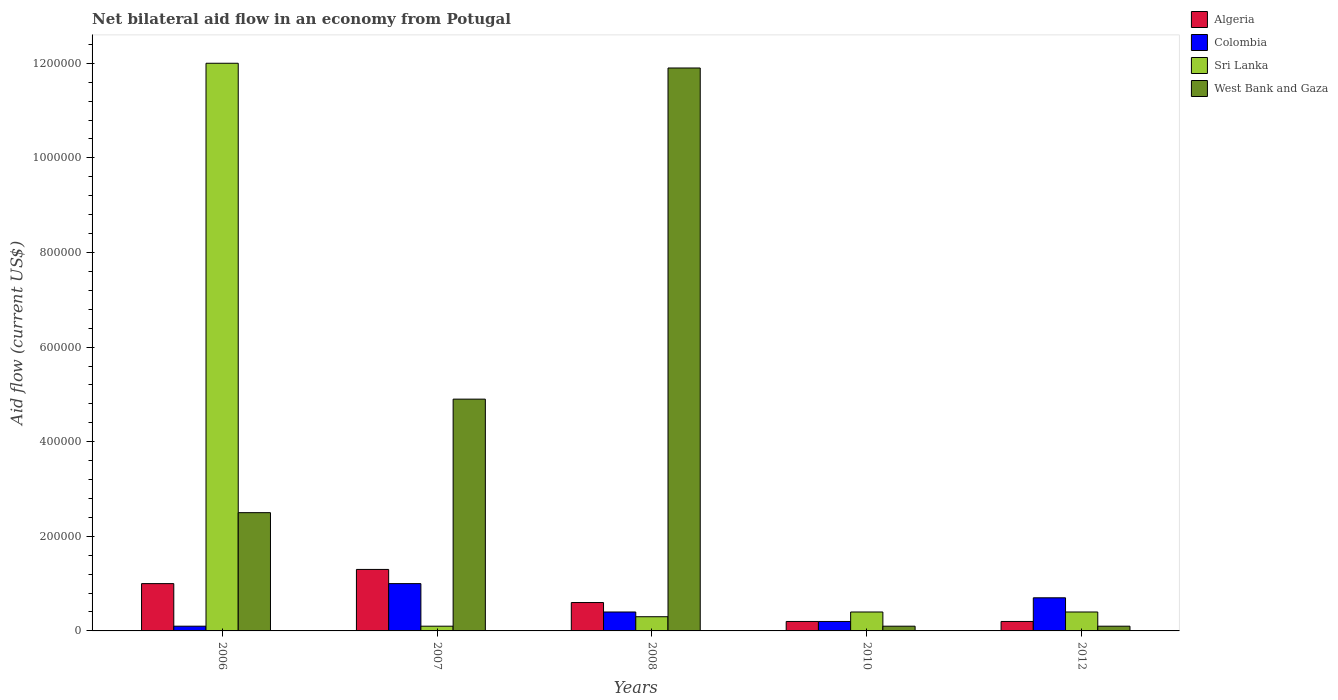How many groups of bars are there?
Provide a short and direct response. 5. Are the number of bars per tick equal to the number of legend labels?
Make the answer very short. Yes. Are the number of bars on each tick of the X-axis equal?
Ensure brevity in your answer.  Yes. How many bars are there on the 5th tick from the right?
Give a very brief answer. 4. In how many cases, is the number of bars for a given year not equal to the number of legend labels?
Your response must be concise. 0. What is the net bilateral aid flow in Sri Lanka in 2010?
Ensure brevity in your answer.  4.00e+04. In which year was the net bilateral aid flow in West Bank and Gaza maximum?
Give a very brief answer. 2008. What is the total net bilateral aid flow in Sri Lanka in the graph?
Offer a very short reply. 1.32e+06. What is the average net bilateral aid flow in Sri Lanka per year?
Provide a succinct answer. 2.64e+05. What is the ratio of the net bilateral aid flow in West Bank and Gaza in 2010 to that in 2012?
Your answer should be compact. 1. Is the difference between the net bilateral aid flow in Colombia in 2007 and 2008 greater than the difference between the net bilateral aid flow in Sri Lanka in 2007 and 2008?
Offer a terse response. Yes. What is the difference between the highest and the second highest net bilateral aid flow in Colombia?
Your answer should be compact. 3.00e+04. What is the difference between the highest and the lowest net bilateral aid flow in Algeria?
Your answer should be compact. 1.10e+05. In how many years, is the net bilateral aid flow in Algeria greater than the average net bilateral aid flow in Algeria taken over all years?
Offer a terse response. 2. Is the sum of the net bilateral aid flow in West Bank and Gaza in 2007 and 2012 greater than the maximum net bilateral aid flow in Colombia across all years?
Offer a very short reply. Yes. Is it the case that in every year, the sum of the net bilateral aid flow in Sri Lanka and net bilateral aid flow in West Bank and Gaza is greater than the sum of net bilateral aid flow in Colombia and net bilateral aid flow in Algeria?
Keep it short and to the point. Yes. What does the 4th bar from the left in 2010 represents?
Offer a terse response. West Bank and Gaza. What does the 2nd bar from the right in 2010 represents?
Make the answer very short. Sri Lanka. Is it the case that in every year, the sum of the net bilateral aid flow in Colombia and net bilateral aid flow in Algeria is greater than the net bilateral aid flow in West Bank and Gaza?
Your answer should be compact. No. How many bars are there?
Make the answer very short. 20. Are the values on the major ticks of Y-axis written in scientific E-notation?
Your response must be concise. No. Does the graph contain any zero values?
Offer a terse response. No. Where does the legend appear in the graph?
Your response must be concise. Top right. How many legend labels are there?
Keep it short and to the point. 4. What is the title of the graph?
Your response must be concise. Net bilateral aid flow in an economy from Potugal. What is the Aid flow (current US$) of Sri Lanka in 2006?
Ensure brevity in your answer.  1.20e+06. What is the Aid flow (current US$) in Algeria in 2007?
Keep it short and to the point. 1.30e+05. What is the Aid flow (current US$) in Sri Lanka in 2007?
Offer a terse response. 10000. What is the Aid flow (current US$) in West Bank and Gaza in 2007?
Make the answer very short. 4.90e+05. What is the Aid flow (current US$) of Algeria in 2008?
Your response must be concise. 6.00e+04. What is the Aid flow (current US$) in Colombia in 2008?
Keep it short and to the point. 4.00e+04. What is the Aid flow (current US$) of Sri Lanka in 2008?
Your response must be concise. 3.00e+04. What is the Aid flow (current US$) in West Bank and Gaza in 2008?
Offer a terse response. 1.19e+06. What is the Aid flow (current US$) in Colombia in 2010?
Offer a terse response. 2.00e+04. What is the Aid flow (current US$) of Algeria in 2012?
Offer a terse response. 2.00e+04. What is the Aid flow (current US$) of Sri Lanka in 2012?
Ensure brevity in your answer.  4.00e+04. Across all years, what is the maximum Aid flow (current US$) in Sri Lanka?
Your answer should be very brief. 1.20e+06. Across all years, what is the maximum Aid flow (current US$) of West Bank and Gaza?
Provide a short and direct response. 1.19e+06. Across all years, what is the minimum Aid flow (current US$) in Algeria?
Provide a succinct answer. 2.00e+04. Across all years, what is the minimum Aid flow (current US$) in West Bank and Gaza?
Make the answer very short. 10000. What is the total Aid flow (current US$) in Algeria in the graph?
Ensure brevity in your answer.  3.30e+05. What is the total Aid flow (current US$) of Colombia in the graph?
Ensure brevity in your answer.  2.40e+05. What is the total Aid flow (current US$) in Sri Lanka in the graph?
Your answer should be very brief. 1.32e+06. What is the total Aid flow (current US$) in West Bank and Gaza in the graph?
Give a very brief answer. 1.95e+06. What is the difference between the Aid flow (current US$) of Sri Lanka in 2006 and that in 2007?
Your answer should be very brief. 1.19e+06. What is the difference between the Aid flow (current US$) in West Bank and Gaza in 2006 and that in 2007?
Your answer should be compact. -2.40e+05. What is the difference between the Aid flow (current US$) in Algeria in 2006 and that in 2008?
Offer a very short reply. 4.00e+04. What is the difference between the Aid flow (current US$) in Sri Lanka in 2006 and that in 2008?
Make the answer very short. 1.17e+06. What is the difference between the Aid flow (current US$) of West Bank and Gaza in 2006 and that in 2008?
Give a very brief answer. -9.40e+05. What is the difference between the Aid flow (current US$) of Sri Lanka in 2006 and that in 2010?
Your answer should be very brief. 1.16e+06. What is the difference between the Aid flow (current US$) of West Bank and Gaza in 2006 and that in 2010?
Make the answer very short. 2.40e+05. What is the difference between the Aid flow (current US$) of Algeria in 2006 and that in 2012?
Offer a terse response. 8.00e+04. What is the difference between the Aid flow (current US$) of Sri Lanka in 2006 and that in 2012?
Provide a succinct answer. 1.16e+06. What is the difference between the Aid flow (current US$) of Algeria in 2007 and that in 2008?
Provide a succinct answer. 7.00e+04. What is the difference between the Aid flow (current US$) of Colombia in 2007 and that in 2008?
Ensure brevity in your answer.  6.00e+04. What is the difference between the Aid flow (current US$) of Sri Lanka in 2007 and that in 2008?
Offer a terse response. -2.00e+04. What is the difference between the Aid flow (current US$) in West Bank and Gaza in 2007 and that in 2008?
Your response must be concise. -7.00e+05. What is the difference between the Aid flow (current US$) of Colombia in 2007 and that in 2010?
Your response must be concise. 8.00e+04. What is the difference between the Aid flow (current US$) of West Bank and Gaza in 2007 and that in 2010?
Ensure brevity in your answer.  4.80e+05. What is the difference between the Aid flow (current US$) in Algeria in 2007 and that in 2012?
Offer a terse response. 1.10e+05. What is the difference between the Aid flow (current US$) in Colombia in 2007 and that in 2012?
Your answer should be compact. 3.00e+04. What is the difference between the Aid flow (current US$) of West Bank and Gaza in 2007 and that in 2012?
Give a very brief answer. 4.80e+05. What is the difference between the Aid flow (current US$) in West Bank and Gaza in 2008 and that in 2010?
Your answer should be very brief. 1.18e+06. What is the difference between the Aid flow (current US$) of Colombia in 2008 and that in 2012?
Your answer should be compact. -3.00e+04. What is the difference between the Aid flow (current US$) in West Bank and Gaza in 2008 and that in 2012?
Keep it short and to the point. 1.18e+06. What is the difference between the Aid flow (current US$) in Algeria in 2010 and that in 2012?
Provide a succinct answer. 0. What is the difference between the Aid flow (current US$) of Sri Lanka in 2010 and that in 2012?
Your answer should be very brief. 0. What is the difference between the Aid flow (current US$) of West Bank and Gaza in 2010 and that in 2012?
Keep it short and to the point. 0. What is the difference between the Aid flow (current US$) in Algeria in 2006 and the Aid flow (current US$) in West Bank and Gaza in 2007?
Give a very brief answer. -3.90e+05. What is the difference between the Aid flow (current US$) of Colombia in 2006 and the Aid flow (current US$) of Sri Lanka in 2007?
Provide a succinct answer. 0. What is the difference between the Aid flow (current US$) in Colombia in 2006 and the Aid flow (current US$) in West Bank and Gaza in 2007?
Make the answer very short. -4.80e+05. What is the difference between the Aid flow (current US$) of Sri Lanka in 2006 and the Aid flow (current US$) of West Bank and Gaza in 2007?
Offer a very short reply. 7.10e+05. What is the difference between the Aid flow (current US$) in Algeria in 2006 and the Aid flow (current US$) in Colombia in 2008?
Make the answer very short. 6.00e+04. What is the difference between the Aid flow (current US$) in Algeria in 2006 and the Aid flow (current US$) in Sri Lanka in 2008?
Keep it short and to the point. 7.00e+04. What is the difference between the Aid flow (current US$) in Algeria in 2006 and the Aid flow (current US$) in West Bank and Gaza in 2008?
Provide a short and direct response. -1.09e+06. What is the difference between the Aid flow (current US$) of Colombia in 2006 and the Aid flow (current US$) of West Bank and Gaza in 2008?
Offer a very short reply. -1.18e+06. What is the difference between the Aid flow (current US$) of Algeria in 2006 and the Aid flow (current US$) of Colombia in 2010?
Make the answer very short. 8.00e+04. What is the difference between the Aid flow (current US$) of Algeria in 2006 and the Aid flow (current US$) of Sri Lanka in 2010?
Provide a short and direct response. 6.00e+04. What is the difference between the Aid flow (current US$) in Algeria in 2006 and the Aid flow (current US$) in West Bank and Gaza in 2010?
Ensure brevity in your answer.  9.00e+04. What is the difference between the Aid flow (current US$) in Sri Lanka in 2006 and the Aid flow (current US$) in West Bank and Gaza in 2010?
Provide a succinct answer. 1.19e+06. What is the difference between the Aid flow (current US$) of Colombia in 2006 and the Aid flow (current US$) of Sri Lanka in 2012?
Offer a terse response. -3.00e+04. What is the difference between the Aid flow (current US$) in Sri Lanka in 2006 and the Aid flow (current US$) in West Bank and Gaza in 2012?
Offer a terse response. 1.19e+06. What is the difference between the Aid flow (current US$) in Algeria in 2007 and the Aid flow (current US$) in West Bank and Gaza in 2008?
Keep it short and to the point. -1.06e+06. What is the difference between the Aid flow (current US$) in Colombia in 2007 and the Aid flow (current US$) in Sri Lanka in 2008?
Offer a very short reply. 7.00e+04. What is the difference between the Aid flow (current US$) of Colombia in 2007 and the Aid flow (current US$) of West Bank and Gaza in 2008?
Your response must be concise. -1.09e+06. What is the difference between the Aid flow (current US$) in Sri Lanka in 2007 and the Aid flow (current US$) in West Bank and Gaza in 2008?
Ensure brevity in your answer.  -1.18e+06. What is the difference between the Aid flow (current US$) in Algeria in 2007 and the Aid flow (current US$) in Sri Lanka in 2010?
Your answer should be compact. 9.00e+04. What is the difference between the Aid flow (current US$) of Colombia in 2007 and the Aid flow (current US$) of Sri Lanka in 2010?
Ensure brevity in your answer.  6.00e+04. What is the difference between the Aid flow (current US$) in Colombia in 2007 and the Aid flow (current US$) in West Bank and Gaza in 2010?
Your answer should be very brief. 9.00e+04. What is the difference between the Aid flow (current US$) of Algeria in 2007 and the Aid flow (current US$) of Colombia in 2012?
Ensure brevity in your answer.  6.00e+04. What is the difference between the Aid flow (current US$) in Colombia in 2007 and the Aid flow (current US$) in Sri Lanka in 2012?
Your answer should be very brief. 6.00e+04. What is the difference between the Aid flow (current US$) in Colombia in 2007 and the Aid flow (current US$) in West Bank and Gaza in 2012?
Provide a short and direct response. 9.00e+04. What is the difference between the Aid flow (current US$) in Colombia in 2008 and the Aid flow (current US$) in West Bank and Gaza in 2010?
Provide a succinct answer. 3.00e+04. What is the difference between the Aid flow (current US$) of Sri Lanka in 2008 and the Aid flow (current US$) of West Bank and Gaza in 2010?
Give a very brief answer. 2.00e+04. What is the difference between the Aid flow (current US$) of Algeria in 2008 and the Aid flow (current US$) of Sri Lanka in 2012?
Give a very brief answer. 2.00e+04. What is the difference between the Aid flow (current US$) in Algeria in 2008 and the Aid flow (current US$) in West Bank and Gaza in 2012?
Ensure brevity in your answer.  5.00e+04. What is the difference between the Aid flow (current US$) in Colombia in 2008 and the Aid flow (current US$) in Sri Lanka in 2012?
Make the answer very short. 0. What is the difference between the Aid flow (current US$) in Colombia in 2008 and the Aid flow (current US$) in West Bank and Gaza in 2012?
Your response must be concise. 3.00e+04. What is the difference between the Aid flow (current US$) in Sri Lanka in 2008 and the Aid flow (current US$) in West Bank and Gaza in 2012?
Keep it short and to the point. 2.00e+04. What is the difference between the Aid flow (current US$) of Algeria in 2010 and the Aid flow (current US$) of Sri Lanka in 2012?
Give a very brief answer. -2.00e+04. What is the difference between the Aid flow (current US$) in Colombia in 2010 and the Aid flow (current US$) in Sri Lanka in 2012?
Provide a succinct answer. -2.00e+04. What is the average Aid flow (current US$) of Algeria per year?
Offer a terse response. 6.60e+04. What is the average Aid flow (current US$) in Colombia per year?
Give a very brief answer. 4.80e+04. What is the average Aid flow (current US$) of Sri Lanka per year?
Provide a succinct answer. 2.64e+05. In the year 2006, what is the difference between the Aid flow (current US$) in Algeria and Aid flow (current US$) in Colombia?
Offer a terse response. 9.00e+04. In the year 2006, what is the difference between the Aid flow (current US$) in Algeria and Aid flow (current US$) in Sri Lanka?
Make the answer very short. -1.10e+06. In the year 2006, what is the difference between the Aid flow (current US$) of Colombia and Aid flow (current US$) of Sri Lanka?
Your answer should be compact. -1.19e+06. In the year 2006, what is the difference between the Aid flow (current US$) of Sri Lanka and Aid flow (current US$) of West Bank and Gaza?
Provide a succinct answer. 9.50e+05. In the year 2007, what is the difference between the Aid flow (current US$) of Algeria and Aid flow (current US$) of Sri Lanka?
Your answer should be very brief. 1.20e+05. In the year 2007, what is the difference between the Aid flow (current US$) in Algeria and Aid flow (current US$) in West Bank and Gaza?
Provide a short and direct response. -3.60e+05. In the year 2007, what is the difference between the Aid flow (current US$) in Colombia and Aid flow (current US$) in West Bank and Gaza?
Offer a terse response. -3.90e+05. In the year 2007, what is the difference between the Aid flow (current US$) of Sri Lanka and Aid flow (current US$) of West Bank and Gaza?
Give a very brief answer. -4.80e+05. In the year 2008, what is the difference between the Aid flow (current US$) in Algeria and Aid flow (current US$) in Colombia?
Ensure brevity in your answer.  2.00e+04. In the year 2008, what is the difference between the Aid flow (current US$) in Algeria and Aid flow (current US$) in Sri Lanka?
Your answer should be very brief. 3.00e+04. In the year 2008, what is the difference between the Aid flow (current US$) in Algeria and Aid flow (current US$) in West Bank and Gaza?
Your response must be concise. -1.13e+06. In the year 2008, what is the difference between the Aid flow (current US$) of Colombia and Aid flow (current US$) of West Bank and Gaza?
Offer a very short reply. -1.15e+06. In the year 2008, what is the difference between the Aid flow (current US$) in Sri Lanka and Aid flow (current US$) in West Bank and Gaza?
Offer a very short reply. -1.16e+06. In the year 2010, what is the difference between the Aid flow (current US$) in Algeria and Aid flow (current US$) in Colombia?
Your answer should be very brief. 0. In the year 2010, what is the difference between the Aid flow (current US$) in Algeria and Aid flow (current US$) in West Bank and Gaza?
Your answer should be very brief. 10000. In the year 2012, what is the difference between the Aid flow (current US$) of Algeria and Aid flow (current US$) of Colombia?
Offer a terse response. -5.00e+04. In the year 2012, what is the difference between the Aid flow (current US$) of Algeria and Aid flow (current US$) of Sri Lanka?
Provide a short and direct response. -2.00e+04. In the year 2012, what is the difference between the Aid flow (current US$) of Algeria and Aid flow (current US$) of West Bank and Gaza?
Make the answer very short. 10000. In the year 2012, what is the difference between the Aid flow (current US$) in Colombia and Aid flow (current US$) in West Bank and Gaza?
Offer a terse response. 6.00e+04. What is the ratio of the Aid flow (current US$) in Algeria in 2006 to that in 2007?
Your answer should be very brief. 0.77. What is the ratio of the Aid flow (current US$) in Colombia in 2006 to that in 2007?
Your answer should be compact. 0.1. What is the ratio of the Aid flow (current US$) of Sri Lanka in 2006 to that in 2007?
Offer a very short reply. 120. What is the ratio of the Aid flow (current US$) in West Bank and Gaza in 2006 to that in 2007?
Provide a succinct answer. 0.51. What is the ratio of the Aid flow (current US$) of Algeria in 2006 to that in 2008?
Give a very brief answer. 1.67. What is the ratio of the Aid flow (current US$) of Colombia in 2006 to that in 2008?
Give a very brief answer. 0.25. What is the ratio of the Aid flow (current US$) in Sri Lanka in 2006 to that in 2008?
Your response must be concise. 40. What is the ratio of the Aid flow (current US$) of West Bank and Gaza in 2006 to that in 2008?
Offer a very short reply. 0.21. What is the ratio of the Aid flow (current US$) of Sri Lanka in 2006 to that in 2010?
Your answer should be compact. 30. What is the ratio of the Aid flow (current US$) of Algeria in 2006 to that in 2012?
Your answer should be compact. 5. What is the ratio of the Aid flow (current US$) of Colombia in 2006 to that in 2012?
Provide a short and direct response. 0.14. What is the ratio of the Aid flow (current US$) in Algeria in 2007 to that in 2008?
Offer a very short reply. 2.17. What is the ratio of the Aid flow (current US$) in Colombia in 2007 to that in 2008?
Your answer should be compact. 2.5. What is the ratio of the Aid flow (current US$) in West Bank and Gaza in 2007 to that in 2008?
Keep it short and to the point. 0.41. What is the ratio of the Aid flow (current US$) in Algeria in 2007 to that in 2012?
Your response must be concise. 6.5. What is the ratio of the Aid flow (current US$) of Colombia in 2007 to that in 2012?
Make the answer very short. 1.43. What is the ratio of the Aid flow (current US$) in Algeria in 2008 to that in 2010?
Make the answer very short. 3. What is the ratio of the Aid flow (current US$) in West Bank and Gaza in 2008 to that in 2010?
Offer a very short reply. 119. What is the ratio of the Aid flow (current US$) in Algeria in 2008 to that in 2012?
Provide a short and direct response. 3. What is the ratio of the Aid flow (current US$) of West Bank and Gaza in 2008 to that in 2012?
Keep it short and to the point. 119. What is the ratio of the Aid flow (current US$) in Algeria in 2010 to that in 2012?
Keep it short and to the point. 1. What is the ratio of the Aid flow (current US$) in Colombia in 2010 to that in 2012?
Keep it short and to the point. 0.29. What is the ratio of the Aid flow (current US$) in West Bank and Gaza in 2010 to that in 2012?
Your response must be concise. 1. What is the difference between the highest and the second highest Aid flow (current US$) of Colombia?
Offer a terse response. 3.00e+04. What is the difference between the highest and the second highest Aid flow (current US$) of Sri Lanka?
Ensure brevity in your answer.  1.16e+06. What is the difference between the highest and the second highest Aid flow (current US$) in West Bank and Gaza?
Offer a terse response. 7.00e+05. What is the difference between the highest and the lowest Aid flow (current US$) of Algeria?
Provide a succinct answer. 1.10e+05. What is the difference between the highest and the lowest Aid flow (current US$) in Colombia?
Give a very brief answer. 9.00e+04. What is the difference between the highest and the lowest Aid flow (current US$) in Sri Lanka?
Provide a short and direct response. 1.19e+06. What is the difference between the highest and the lowest Aid flow (current US$) in West Bank and Gaza?
Provide a succinct answer. 1.18e+06. 